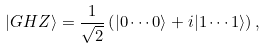Convert formula to latex. <formula><loc_0><loc_0><loc_500><loc_500>| G H Z \rangle = \frac { 1 } { \sqrt { 2 } } \left ( | 0 \cdots 0 \rangle + i | 1 \cdots 1 \rangle \right ) ,</formula> 